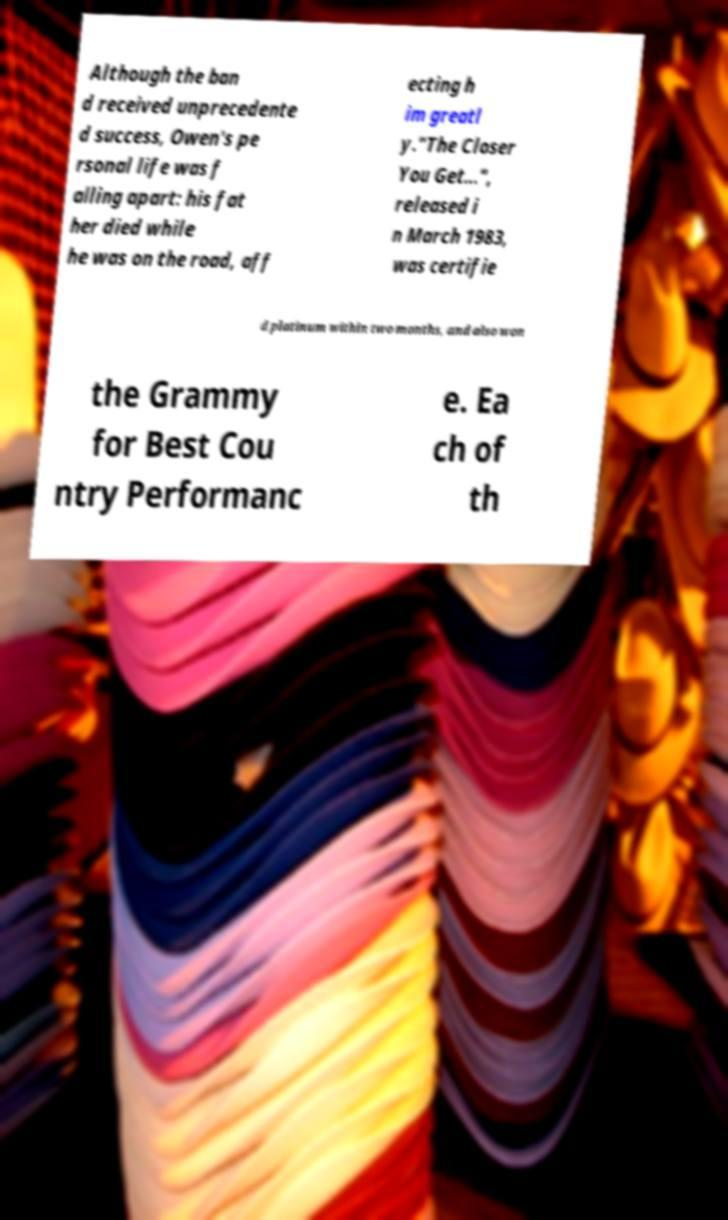Please read and relay the text visible in this image. What does it say? Although the ban d received unprecedente d success, Owen's pe rsonal life was f alling apart: his fat her died while he was on the road, aff ecting h im greatl y."The Closer You Get...", released i n March 1983, was certifie d platinum within two months, and also won the Grammy for Best Cou ntry Performanc e. Ea ch of th 